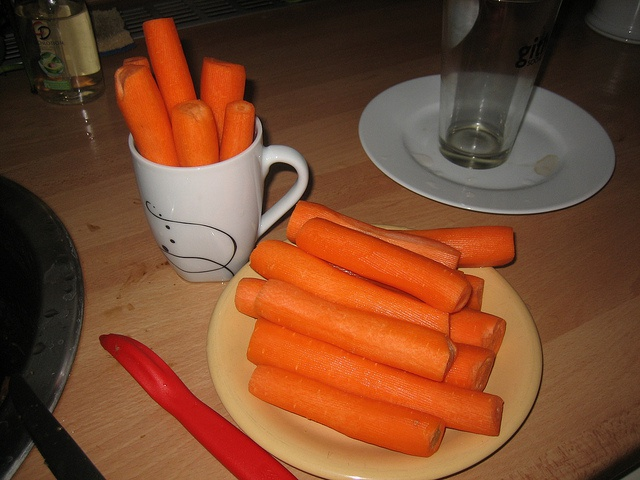Describe the objects in this image and their specific colors. I can see dining table in black, maroon, and gray tones, carrot in black, red, and brown tones, cup in black, red, darkgray, and brown tones, cup in black and gray tones, and bottle in black and olive tones in this image. 